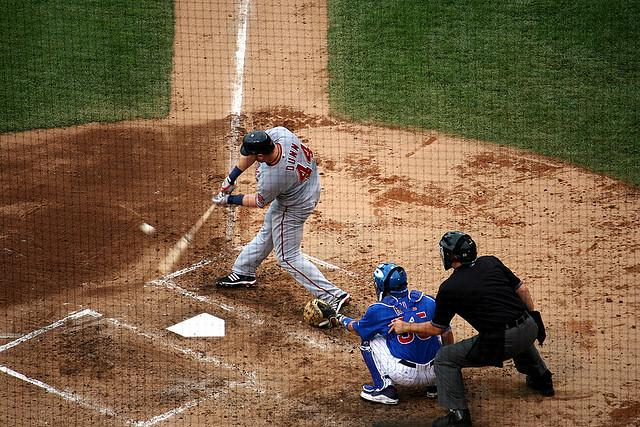What is number 44 doing?

Choices:
A) running away
B) sliding down
C) hitting ball
D) swinging bat swinging bat 